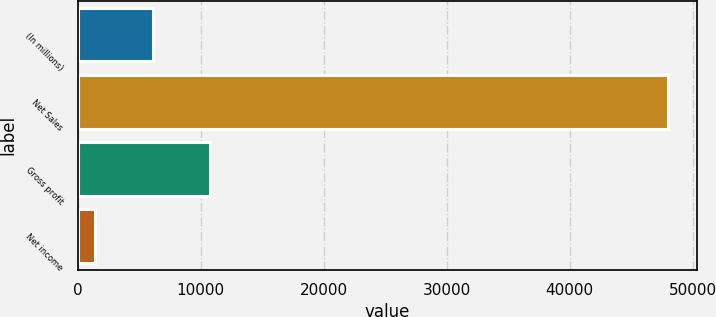<chart> <loc_0><loc_0><loc_500><loc_500><bar_chart><fcel>(In millions)<fcel>Net Sales<fcel>Gross profit<fcel>Net income<nl><fcel>6083.2<fcel>47980<fcel>10738.4<fcel>1428<nl></chart> 